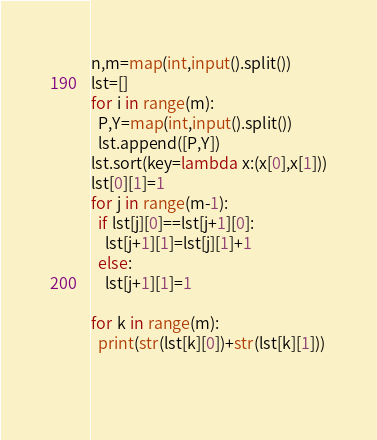<code> <loc_0><loc_0><loc_500><loc_500><_Python_>n,m=map(int,input().split())
lst=[]
for i in range(m):
  P,Y=map(int,input().split())
  lst.append([P,Y])
lst.sort(key=lambda x:(x[0],x[1]))
lst[0][1]=1
for j in range(m-1):
  if lst[j][0]==lst[j+1][0]:
    lst[j+1][1]=lst[j][1]+1
  else:
    lst[j+1][1]=1

for k in range(m):
  print(str(lst[k][0])+str(lst[k][1]))
  
  



</code> 